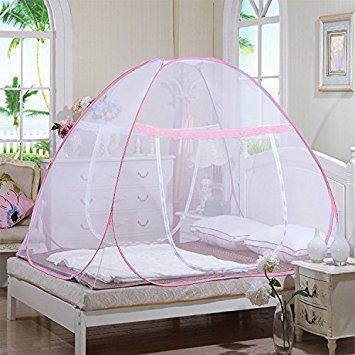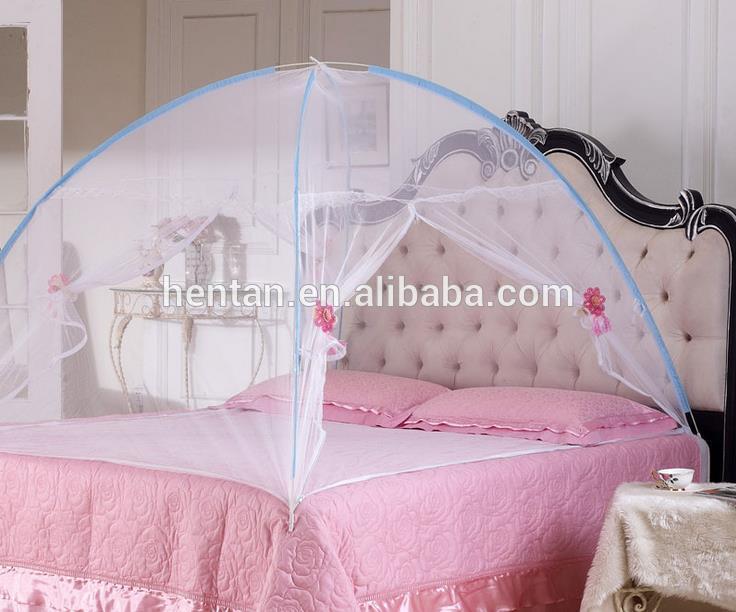The first image is the image on the left, the second image is the image on the right. Assess this claim about the two images: "At least one of the beds has a pink bedspread.". Correct or not? Answer yes or no. Yes. 